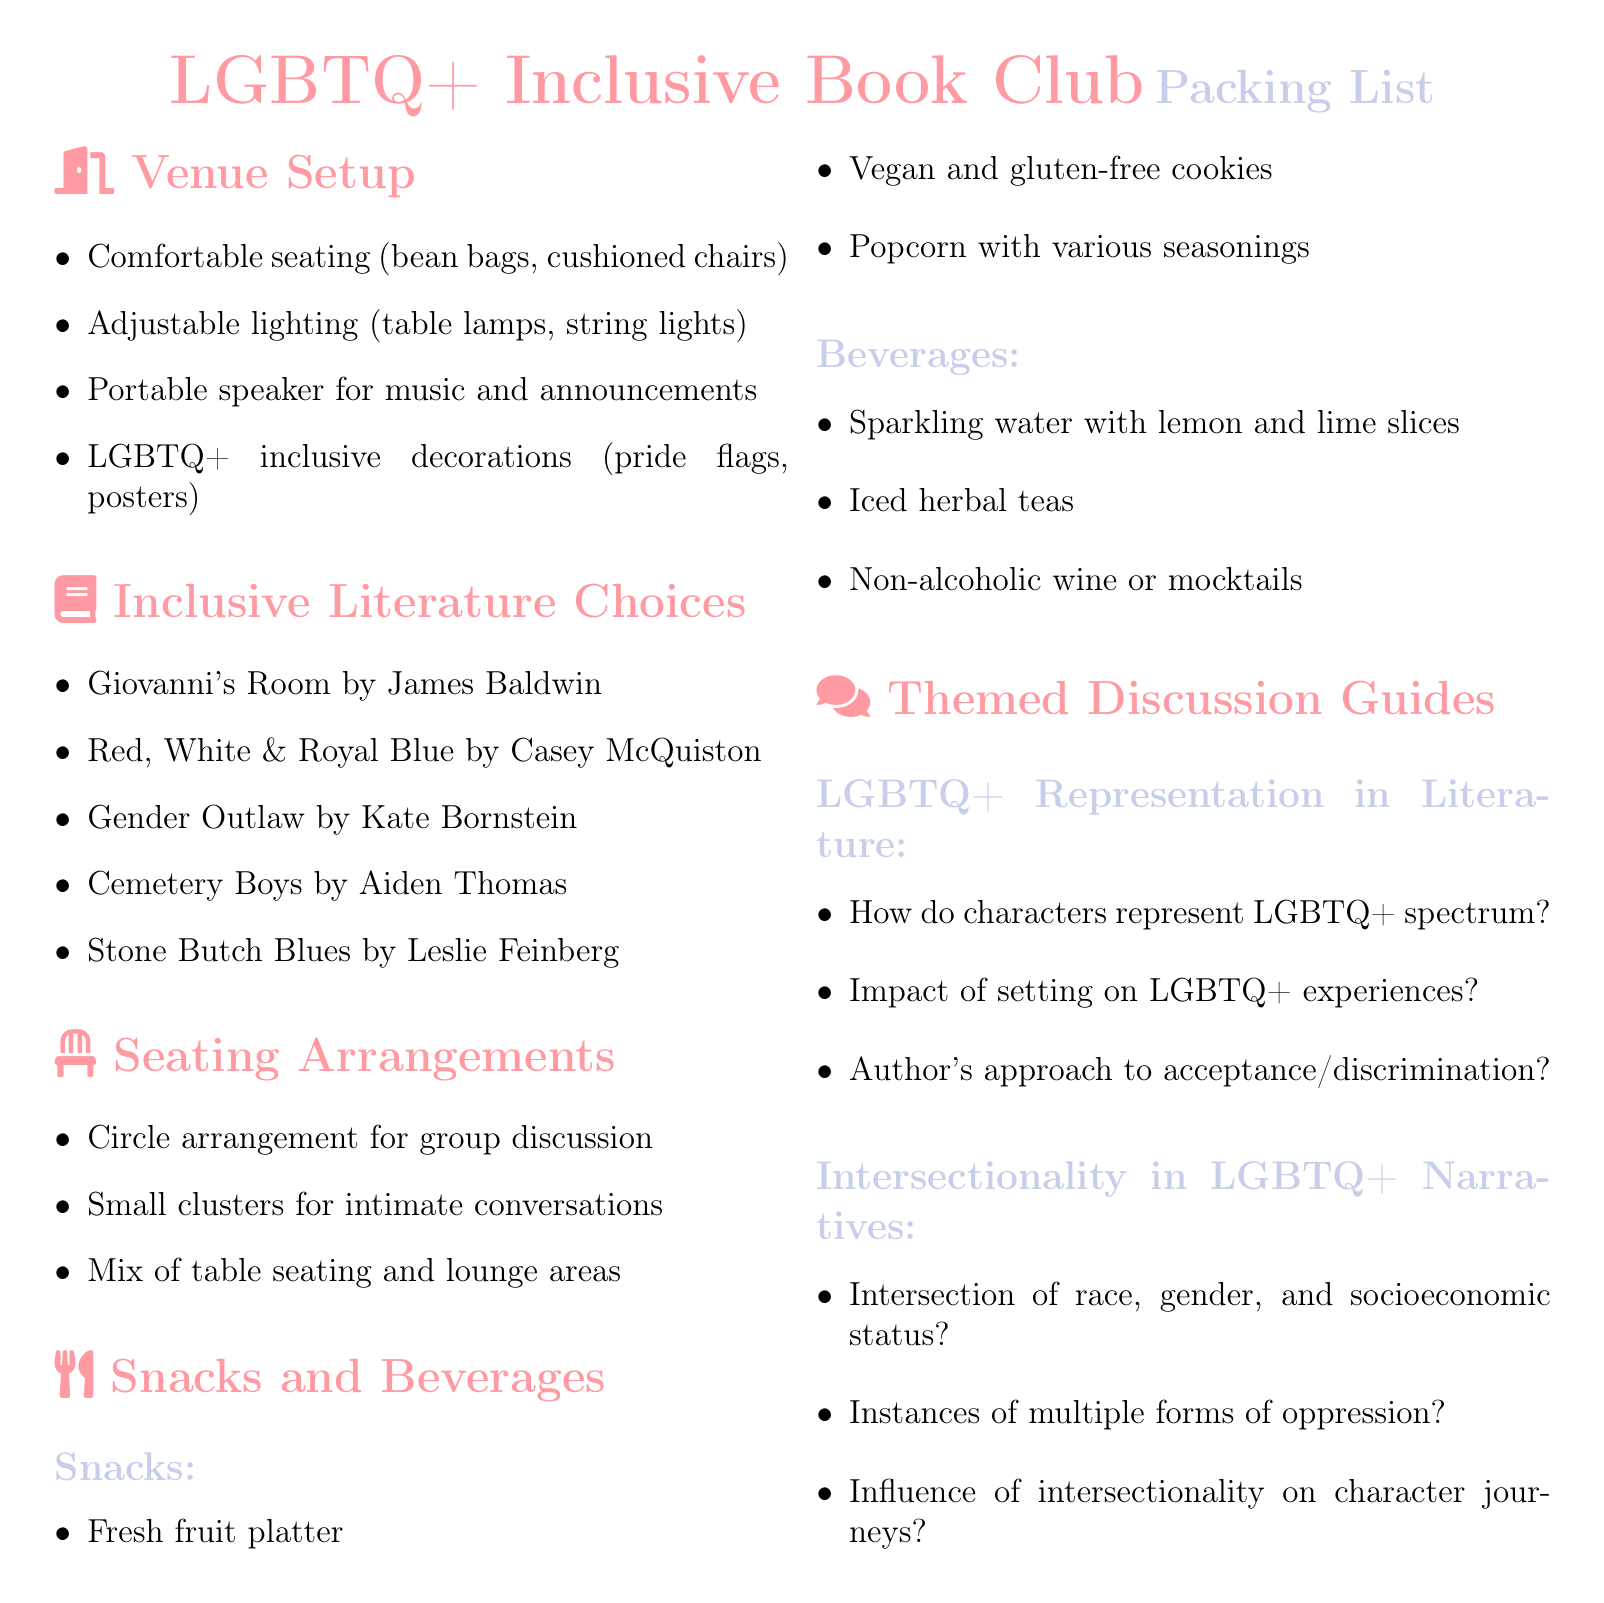What is the title of the book by James Baldwin? The title listed under inclusive literature choices is "Giovanni's Room."
Answer: Giovanni's Room How many snacks are listed in the snacks section? There are three types of snacks mentioned in the document: fresh fruit platter, vegan and gluten-free cookies, and popcorn.
Answer: 3 What is one type of seating arrangement suggested? The document mentions a circle arrangement for group discussion as a seating option.
Answer: Circle arrangement Name one beverage option provided in the beverages section. The beverages section lists several options, one of which is sparkling water with lemon and lime slices.
Answer: Sparkling water What is one theme suggested for the discussion guide? The discussion guide includes themes such as LGBTQ+ Representation in Literature as one of the topics for discussion.
Answer: LGBTQ+ Representation in Literature What kind of cookies are included in the snack options? The snack options specifically mention "vegan and gluten-free cookies."
Answer: Vegan and gluten-free cookies How many LGBTQ+ inclusive decorations are suggested for venue setup? The document points out that LGBTQ+ inclusive decorations should include pride flags and posters, among others; however, it does not specify a number.
Answer: Not specified What type of lighting is recommended for the venue? The venue setup suggests using adjustable lighting like table lamps and string lights.
Answer: Adjustable lighting 